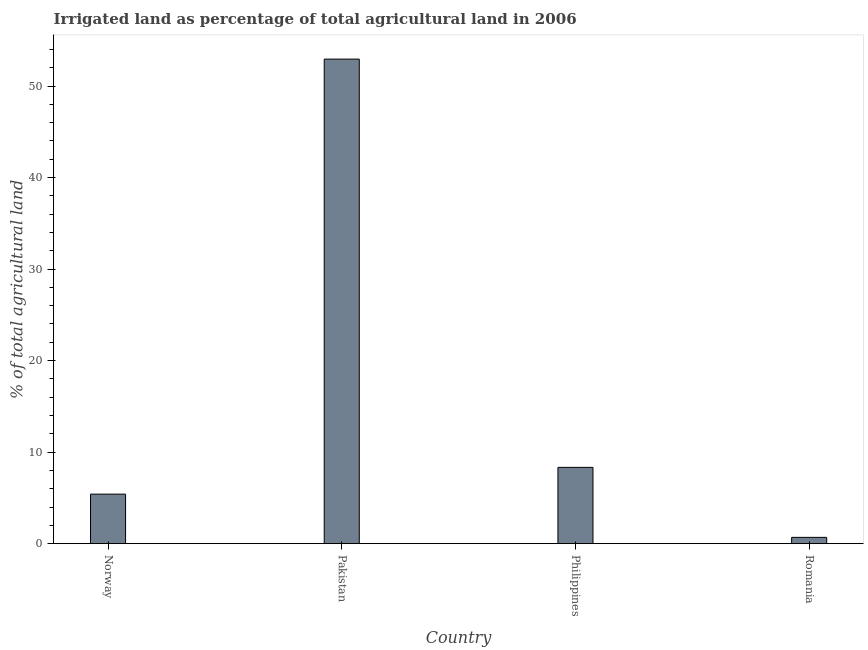What is the title of the graph?
Ensure brevity in your answer.  Irrigated land as percentage of total agricultural land in 2006. What is the label or title of the X-axis?
Your answer should be very brief. Country. What is the label or title of the Y-axis?
Your response must be concise. % of total agricultural land. What is the percentage of agricultural irrigated land in Philippines?
Your answer should be compact. 8.33. Across all countries, what is the maximum percentage of agricultural irrigated land?
Give a very brief answer. 52.94. Across all countries, what is the minimum percentage of agricultural irrigated land?
Your answer should be very brief. 0.69. In which country was the percentage of agricultural irrigated land minimum?
Your response must be concise. Romania. What is the sum of the percentage of agricultural irrigated land?
Keep it short and to the point. 67.37. What is the difference between the percentage of agricultural irrigated land in Norway and Romania?
Give a very brief answer. 4.72. What is the average percentage of agricultural irrigated land per country?
Keep it short and to the point. 16.84. What is the median percentage of agricultural irrigated land?
Your response must be concise. 6.87. In how many countries, is the percentage of agricultural irrigated land greater than 30 %?
Ensure brevity in your answer.  1. What is the ratio of the percentage of agricultural irrigated land in Philippines to that in Romania?
Give a very brief answer. 12.12. Is the percentage of agricultural irrigated land in Pakistan less than that in Philippines?
Provide a succinct answer. No. What is the difference between the highest and the second highest percentage of agricultural irrigated land?
Offer a terse response. 44.61. Is the sum of the percentage of agricultural irrigated land in Philippines and Romania greater than the maximum percentage of agricultural irrigated land across all countries?
Offer a very short reply. No. What is the difference between the highest and the lowest percentage of agricultural irrigated land?
Offer a very short reply. 52.25. In how many countries, is the percentage of agricultural irrigated land greater than the average percentage of agricultural irrigated land taken over all countries?
Provide a short and direct response. 1. Are the values on the major ticks of Y-axis written in scientific E-notation?
Your response must be concise. No. What is the % of total agricultural land in Norway?
Offer a very short reply. 5.41. What is the % of total agricultural land in Pakistan?
Your response must be concise. 52.94. What is the % of total agricultural land in Philippines?
Your answer should be very brief. 8.33. What is the % of total agricultural land in Romania?
Give a very brief answer. 0.69. What is the difference between the % of total agricultural land in Norway and Pakistan?
Provide a succinct answer. -47.53. What is the difference between the % of total agricultural land in Norway and Philippines?
Provide a succinct answer. -2.92. What is the difference between the % of total agricultural land in Norway and Romania?
Make the answer very short. 4.72. What is the difference between the % of total agricultural land in Pakistan and Philippines?
Provide a short and direct response. 44.61. What is the difference between the % of total agricultural land in Pakistan and Romania?
Keep it short and to the point. 52.25. What is the difference between the % of total agricultural land in Philippines and Romania?
Provide a succinct answer. 7.65. What is the ratio of the % of total agricultural land in Norway to that in Pakistan?
Provide a short and direct response. 0.1. What is the ratio of the % of total agricultural land in Norway to that in Philippines?
Offer a very short reply. 0.65. What is the ratio of the % of total agricultural land in Norway to that in Romania?
Provide a succinct answer. 7.87. What is the ratio of the % of total agricultural land in Pakistan to that in Philippines?
Your answer should be compact. 6.35. What is the ratio of the % of total agricultural land in Pakistan to that in Romania?
Your response must be concise. 77.02. What is the ratio of the % of total agricultural land in Philippines to that in Romania?
Your answer should be compact. 12.12. 